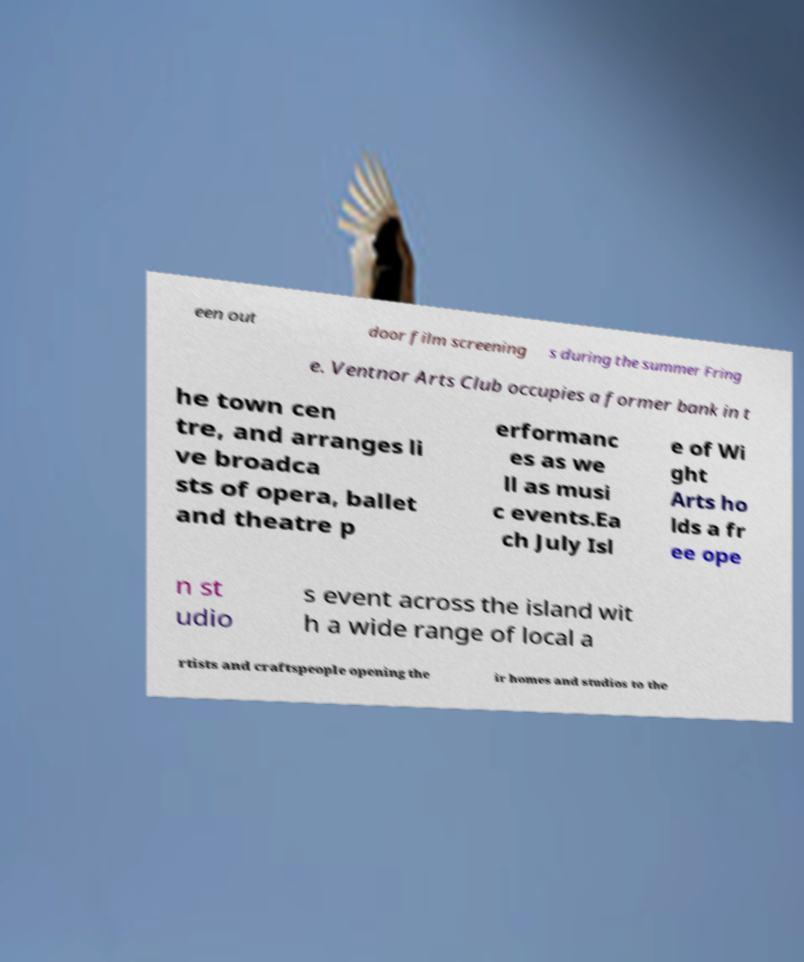For documentation purposes, I need the text within this image transcribed. Could you provide that? een out door film screening s during the summer Fring e. Ventnor Arts Club occupies a former bank in t he town cen tre, and arranges li ve broadca sts of opera, ballet and theatre p erformanc es as we ll as musi c events.Ea ch July Isl e of Wi ght Arts ho lds a fr ee ope n st udio s event across the island wit h a wide range of local a rtists and craftspeople opening the ir homes and studios to the 